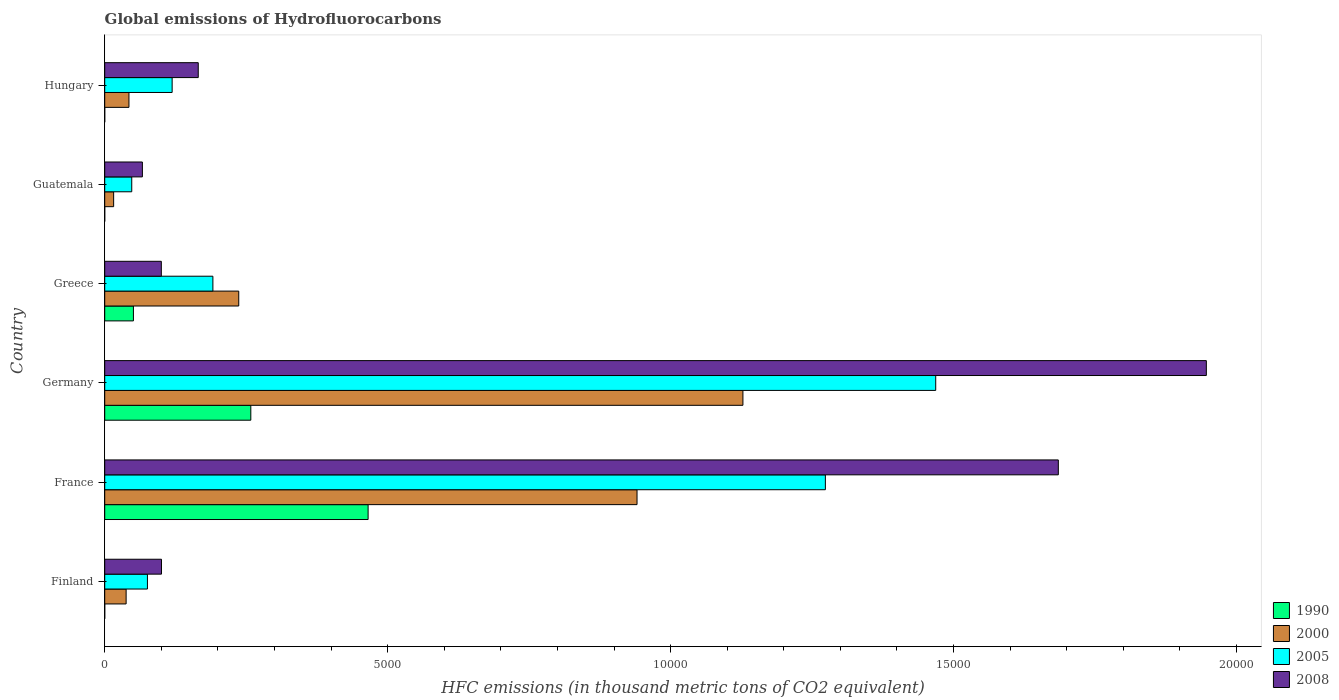How many different coloured bars are there?
Make the answer very short. 4. In how many cases, is the number of bars for a given country not equal to the number of legend labels?
Provide a succinct answer. 0. What is the global emissions of Hydrofluorocarbons in 2000 in Germany?
Your answer should be very brief. 1.13e+04. Across all countries, what is the maximum global emissions of Hydrofluorocarbons in 2000?
Provide a succinct answer. 1.13e+04. Across all countries, what is the minimum global emissions of Hydrofluorocarbons in 2008?
Your answer should be compact. 665.8. In which country was the global emissions of Hydrofluorocarbons in 2008 maximum?
Offer a terse response. Germany. In which country was the global emissions of Hydrofluorocarbons in 2005 minimum?
Keep it short and to the point. Guatemala. What is the total global emissions of Hydrofluorocarbons in 1990 in the graph?
Offer a terse response. 7743.3. What is the difference between the global emissions of Hydrofluorocarbons in 2000 in France and that in Greece?
Your answer should be very brief. 7038. What is the difference between the global emissions of Hydrofluorocarbons in 1990 in Greece and the global emissions of Hydrofluorocarbons in 2000 in Hungary?
Offer a very short reply. 79. What is the average global emissions of Hydrofluorocarbons in 2008 per country?
Your answer should be very brief. 6773.35. What is the difference between the global emissions of Hydrofluorocarbons in 2000 and global emissions of Hydrofluorocarbons in 1990 in Finland?
Keep it short and to the point. 378.1. What is the ratio of the global emissions of Hydrofluorocarbons in 1990 in Finland to that in Guatemala?
Your response must be concise. 1. Is the difference between the global emissions of Hydrofluorocarbons in 2000 in Greece and Hungary greater than the difference between the global emissions of Hydrofluorocarbons in 1990 in Greece and Hungary?
Keep it short and to the point. Yes. What is the difference between the highest and the second highest global emissions of Hydrofluorocarbons in 2005?
Your answer should be compact. 1949.9. What is the difference between the highest and the lowest global emissions of Hydrofluorocarbons in 2005?
Make the answer very short. 1.42e+04. Is it the case that in every country, the sum of the global emissions of Hydrofluorocarbons in 1990 and global emissions of Hydrofluorocarbons in 2005 is greater than the sum of global emissions of Hydrofluorocarbons in 2008 and global emissions of Hydrofluorocarbons in 2000?
Provide a succinct answer. No. Is it the case that in every country, the sum of the global emissions of Hydrofluorocarbons in 2005 and global emissions of Hydrofluorocarbons in 2008 is greater than the global emissions of Hydrofluorocarbons in 1990?
Give a very brief answer. Yes. How many countries are there in the graph?
Ensure brevity in your answer.  6. What is the difference between two consecutive major ticks on the X-axis?
Give a very brief answer. 5000. Does the graph contain any zero values?
Ensure brevity in your answer.  No. How are the legend labels stacked?
Provide a short and direct response. Vertical. What is the title of the graph?
Keep it short and to the point. Global emissions of Hydrofluorocarbons. What is the label or title of the X-axis?
Give a very brief answer. HFC emissions (in thousand metric tons of CO2 equivalent). What is the label or title of the Y-axis?
Your answer should be very brief. Country. What is the HFC emissions (in thousand metric tons of CO2 equivalent) in 1990 in Finland?
Provide a short and direct response. 0.1. What is the HFC emissions (in thousand metric tons of CO2 equivalent) in 2000 in Finland?
Give a very brief answer. 378.2. What is the HFC emissions (in thousand metric tons of CO2 equivalent) of 2005 in Finland?
Keep it short and to the point. 754.9. What is the HFC emissions (in thousand metric tons of CO2 equivalent) in 2008 in Finland?
Ensure brevity in your answer.  1003.2. What is the HFC emissions (in thousand metric tons of CO2 equivalent) of 1990 in France?
Offer a terse response. 4654.3. What is the HFC emissions (in thousand metric tons of CO2 equivalent) of 2000 in France?
Keep it short and to the point. 9406.4. What is the HFC emissions (in thousand metric tons of CO2 equivalent) in 2005 in France?
Provide a short and direct response. 1.27e+04. What is the HFC emissions (in thousand metric tons of CO2 equivalent) in 2008 in France?
Your answer should be very brief. 1.69e+04. What is the HFC emissions (in thousand metric tons of CO2 equivalent) in 1990 in Germany?
Keep it short and to the point. 2581.5. What is the HFC emissions (in thousand metric tons of CO2 equivalent) of 2000 in Germany?
Offer a very short reply. 1.13e+04. What is the HFC emissions (in thousand metric tons of CO2 equivalent) in 2005 in Germany?
Ensure brevity in your answer.  1.47e+04. What is the HFC emissions (in thousand metric tons of CO2 equivalent) of 2008 in Germany?
Ensure brevity in your answer.  1.95e+04. What is the HFC emissions (in thousand metric tons of CO2 equivalent) in 1990 in Greece?
Make the answer very short. 507.2. What is the HFC emissions (in thousand metric tons of CO2 equivalent) in 2000 in Greece?
Keep it short and to the point. 2368.4. What is the HFC emissions (in thousand metric tons of CO2 equivalent) of 2005 in Greece?
Your answer should be very brief. 1911.4. What is the HFC emissions (in thousand metric tons of CO2 equivalent) of 2008 in Greece?
Your answer should be compact. 1000.3. What is the HFC emissions (in thousand metric tons of CO2 equivalent) in 1990 in Guatemala?
Make the answer very short. 0.1. What is the HFC emissions (in thousand metric tons of CO2 equivalent) of 2000 in Guatemala?
Offer a terse response. 157.6. What is the HFC emissions (in thousand metric tons of CO2 equivalent) of 2005 in Guatemala?
Your answer should be compact. 477.8. What is the HFC emissions (in thousand metric tons of CO2 equivalent) in 2008 in Guatemala?
Offer a terse response. 665.8. What is the HFC emissions (in thousand metric tons of CO2 equivalent) of 2000 in Hungary?
Your response must be concise. 428.2. What is the HFC emissions (in thousand metric tons of CO2 equivalent) of 2005 in Hungary?
Make the answer very short. 1191.4. What is the HFC emissions (in thousand metric tons of CO2 equivalent) in 2008 in Hungary?
Your answer should be compact. 1652.9. Across all countries, what is the maximum HFC emissions (in thousand metric tons of CO2 equivalent) of 1990?
Ensure brevity in your answer.  4654.3. Across all countries, what is the maximum HFC emissions (in thousand metric tons of CO2 equivalent) of 2000?
Provide a succinct answer. 1.13e+04. Across all countries, what is the maximum HFC emissions (in thousand metric tons of CO2 equivalent) in 2005?
Offer a terse response. 1.47e+04. Across all countries, what is the maximum HFC emissions (in thousand metric tons of CO2 equivalent) in 2008?
Keep it short and to the point. 1.95e+04. Across all countries, what is the minimum HFC emissions (in thousand metric tons of CO2 equivalent) in 1990?
Provide a succinct answer. 0.1. Across all countries, what is the minimum HFC emissions (in thousand metric tons of CO2 equivalent) in 2000?
Provide a short and direct response. 157.6. Across all countries, what is the minimum HFC emissions (in thousand metric tons of CO2 equivalent) in 2005?
Your answer should be compact. 477.8. Across all countries, what is the minimum HFC emissions (in thousand metric tons of CO2 equivalent) of 2008?
Give a very brief answer. 665.8. What is the total HFC emissions (in thousand metric tons of CO2 equivalent) of 1990 in the graph?
Your response must be concise. 7743.3. What is the total HFC emissions (in thousand metric tons of CO2 equivalent) of 2000 in the graph?
Offer a very short reply. 2.40e+04. What is the total HFC emissions (in thousand metric tons of CO2 equivalent) in 2005 in the graph?
Give a very brief answer. 3.18e+04. What is the total HFC emissions (in thousand metric tons of CO2 equivalent) of 2008 in the graph?
Your response must be concise. 4.06e+04. What is the difference between the HFC emissions (in thousand metric tons of CO2 equivalent) of 1990 in Finland and that in France?
Offer a terse response. -4654.2. What is the difference between the HFC emissions (in thousand metric tons of CO2 equivalent) of 2000 in Finland and that in France?
Your answer should be compact. -9028.2. What is the difference between the HFC emissions (in thousand metric tons of CO2 equivalent) of 2005 in Finland and that in France?
Make the answer very short. -1.20e+04. What is the difference between the HFC emissions (in thousand metric tons of CO2 equivalent) in 2008 in Finland and that in France?
Give a very brief answer. -1.58e+04. What is the difference between the HFC emissions (in thousand metric tons of CO2 equivalent) of 1990 in Finland and that in Germany?
Ensure brevity in your answer.  -2581.4. What is the difference between the HFC emissions (in thousand metric tons of CO2 equivalent) in 2000 in Finland and that in Germany?
Ensure brevity in your answer.  -1.09e+04. What is the difference between the HFC emissions (in thousand metric tons of CO2 equivalent) of 2005 in Finland and that in Germany?
Provide a short and direct response. -1.39e+04. What is the difference between the HFC emissions (in thousand metric tons of CO2 equivalent) in 2008 in Finland and that in Germany?
Offer a terse response. -1.85e+04. What is the difference between the HFC emissions (in thousand metric tons of CO2 equivalent) of 1990 in Finland and that in Greece?
Your response must be concise. -507.1. What is the difference between the HFC emissions (in thousand metric tons of CO2 equivalent) of 2000 in Finland and that in Greece?
Keep it short and to the point. -1990.2. What is the difference between the HFC emissions (in thousand metric tons of CO2 equivalent) in 2005 in Finland and that in Greece?
Your response must be concise. -1156.5. What is the difference between the HFC emissions (in thousand metric tons of CO2 equivalent) in 2008 in Finland and that in Greece?
Provide a succinct answer. 2.9. What is the difference between the HFC emissions (in thousand metric tons of CO2 equivalent) in 1990 in Finland and that in Guatemala?
Your answer should be compact. 0. What is the difference between the HFC emissions (in thousand metric tons of CO2 equivalent) of 2000 in Finland and that in Guatemala?
Offer a very short reply. 220.6. What is the difference between the HFC emissions (in thousand metric tons of CO2 equivalent) in 2005 in Finland and that in Guatemala?
Offer a very short reply. 277.1. What is the difference between the HFC emissions (in thousand metric tons of CO2 equivalent) of 2008 in Finland and that in Guatemala?
Provide a short and direct response. 337.4. What is the difference between the HFC emissions (in thousand metric tons of CO2 equivalent) in 1990 in Finland and that in Hungary?
Offer a terse response. 0. What is the difference between the HFC emissions (in thousand metric tons of CO2 equivalent) in 2000 in Finland and that in Hungary?
Your response must be concise. -50. What is the difference between the HFC emissions (in thousand metric tons of CO2 equivalent) of 2005 in Finland and that in Hungary?
Ensure brevity in your answer.  -436.5. What is the difference between the HFC emissions (in thousand metric tons of CO2 equivalent) in 2008 in Finland and that in Hungary?
Your response must be concise. -649.7. What is the difference between the HFC emissions (in thousand metric tons of CO2 equivalent) of 1990 in France and that in Germany?
Your response must be concise. 2072.8. What is the difference between the HFC emissions (in thousand metric tons of CO2 equivalent) in 2000 in France and that in Germany?
Your answer should be very brief. -1871.2. What is the difference between the HFC emissions (in thousand metric tons of CO2 equivalent) of 2005 in France and that in Germany?
Provide a short and direct response. -1949.9. What is the difference between the HFC emissions (in thousand metric tons of CO2 equivalent) of 2008 in France and that in Germany?
Your answer should be compact. -2615.7. What is the difference between the HFC emissions (in thousand metric tons of CO2 equivalent) in 1990 in France and that in Greece?
Provide a succinct answer. 4147.1. What is the difference between the HFC emissions (in thousand metric tons of CO2 equivalent) of 2000 in France and that in Greece?
Your response must be concise. 7038. What is the difference between the HFC emissions (in thousand metric tons of CO2 equivalent) in 2005 in France and that in Greece?
Your answer should be compact. 1.08e+04. What is the difference between the HFC emissions (in thousand metric tons of CO2 equivalent) of 2008 in France and that in Greece?
Offer a very short reply. 1.59e+04. What is the difference between the HFC emissions (in thousand metric tons of CO2 equivalent) in 1990 in France and that in Guatemala?
Provide a succinct answer. 4654.2. What is the difference between the HFC emissions (in thousand metric tons of CO2 equivalent) in 2000 in France and that in Guatemala?
Give a very brief answer. 9248.8. What is the difference between the HFC emissions (in thousand metric tons of CO2 equivalent) of 2005 in France and that in Guatemala?
Ensure brevity in your answer.  1.23e+04. What is the difference between the HFC emissions (in thousand metric tons of CO2 equivalent) of 2008 in France and that in Guatemala?
Offer a very short reply. 1.62e+04. What is the difference between the HFC emissions (in thousand metric tons of CO2 equivalent) in 1990 in France and that in Hungary?
Your answer should be compact. 4654.2. What is the difference between the HFC emissions (in thousand metric tons of CO2 equivalent) in 2000 in France and that in Hungary?
Offer a very short reply. 8978.2. What is the difference between the HFC emissions (in thousand metric tons of CO2 equivalent) of 2005 in France and that in Hungary?
Provide a short and direct response. 1.15e+04. What is the difference between the HFC emissions (in thousand metric tons of CO2 equivalent) of 2008 in France and that in Hungary?
Keep it short and to the point. 1.52e+04. What is the difference between the HFC emissions (in thousand metric tons of CO2 equivalent) in 1990 in Germany and that in Greece?
Your answer should be compact. 2074.3. What is the difference between the HFC emissions (in thousand metric tons of CO2 equivalent) in 2000 in Germany and that in Greece?
Provide a succinct answer. 8909.2. What is the difference between the HFC emissions (in thousand metric tons of CO2 equivalent) of 2005 in Germany and that in Greece?
Offer a very short reply. 1.28e+04. What is the difference between the HFC emissions (in thousand metric tons of CO2 equivalent) in 2008 in Germany and that in Greece?
Provide a succinct answer. 1.85e+04. What is the difference between the HFC emissions (in thousand metric tons of CO2 equivalent) in 1990 in Germany and that in Guatemala?
Make the answer very short. 2581.4. What is the difference between the HFC emissions (in thousand metric tons of CO2 equivalent) in 2000 in Germany and that in Guatemala?
Your answer should be very brief. 1.11e+04. What is the difference between the HFC emissions (in thousand metric tons of CO2 equivalent) of 2005 in Germany and that in Guatemala?
Provide a short and direct response. 1.42e+04. What is the difference between the HFC emissions (in thousand metric tons of CO2 equivalent) in 2008 in Germany and that in Guatemala?
Make the answer very short. 1.88e+04. What is the difference between the HFC emissions (in thousand metric tons of CO2 equivalent) in 1990 in Germany and that in Hungary?
Provide a short and direct response. 2581.4. What is the difference between the HFC emissions (in thousand metric tons of CO2 equivalent) in 2000 in Germany and that in Hungary?
Your answer should be compact. 1.08e+04. What is the difference between the HFC emissions (in thousand metric tons of CO2 equivalent) of 2005 in Germany and that in Hungary?
Your answer should be very brief. 1.35e+04. What is the difference between the HFC emissions (in thousand metric tons of CO2 equivalent) of 2008 in Germany and that in Hungary?
Offer a very short reply. 1.78e+04. What is the difference between the HFC emissions (in thousand metric tons of CO2 equivalent) in 1990 in Greece and that in Guatemala?
Offer a terse response. 507.1. What is the difference between the HFC emissions (in thousand metric tons of CO2 equivalent) in 2000 in Greece and that in Guatemala?
Offer a very short reply. 2210.8. What is the difference between the HFC emissions (in thousand metric tons of CO2 equivalent) in 2005 in Greece and that in Guatemala?
Give a very brief answer. 1433.6. What is the difference between the HFC emissions (in thousand metric tons of CO2 equivalent) of 2008 in Greece and that in Guatemala?
Provide a short and direct response. 334.5. What is the difference between the HFC emissions (in thousand metric tons of CO2 equivalent) in 1990 in Greece and that in Hungary?
Provide a short and direct response. 507.1. What is the difference between the HFC emissions (in thousand metric tons of CO2 equivalent) of 2000 in Greece and that in Hungary?
Offer a terse response. 1940.2. What is the difference between the HFC emissions (in thousand metric tons of CO2 equivalent) of 2005 in Greece and that in Hungary?
Give a very brief answer. 720. What is the difference between the HFC emissions (in thousand metric tons of CO2 equivalent) of 2008 in Greece and that in Hungary?
Offer a very short reply. -652.6. What is the difference between the HFC emissions (in thousand metric tons of CO2 equivalent) of 2000 in Guatemala and that in Hungary?
Give a very brief answer. -270.6. What is the difference between the HFC emissions (in thousand metric tons of CO2 equivalent) of 2005 in Guatemala and that in Hungary?
Your response must be concise. -713.6. What is the difference between the HFC emissions (in thousand metric tons of CO2 equivalent) of 2008 in Guatemala and that in Hungary?
Make the answer very short. -987.1. What is the difference between the HFC emissions (in thousand metric tons of CO2 equivalent) of 1990 in Finland and the HFC emissions (in thousand metric tons of CO2 equivalent) of 2000 in France?
Ensure brevity in your answer.  -9406.3. What is the difference between the HFC emissions (in thousand metric tons of CO2 equivalent) in 1990 in Finland and the HFC emissions (in thousand metric tons of CO2 equivalent) in 2005 in France?
Make the answer very short. -1.27e+04. What is the difference between the HFC emissions (in thousand metric tons of CO2 equivalent) in 1990 in Finland and the HFC emissions (in thousand metric tons of CO2 equivalent) in 2008 in France?
Your answer should be very brief. -1.69e+04. What is the difference between the HFC emissions (in thousand metric tons of CO2 equivalent) in 2000 in Finland and the HFC emissions (in thousand metric tons of CO2 equivalent) in 2005 in France?
Offer a very short reply. -1.24e+04. What is the difference between the HFC emissions (in thousand metric tons of CO2 equivalent) of 2000 in Finland and the HFC emissions (in thousand metric tons of CO2 equivalent) of 2008 in France?
Your response must be concise. -1.65e+04. What is the difference between the HFC emissions (in thousand metric tons of CO2 equivalent) of 2005 in Finland and the HFC emissions (in thousand metric tons of CO2 equivalent) of 2008 in France?
Your answer should be very brief. -1.61e+04. What is the difference between the HFC emissions (in thousand metric tons of CO2 equivalent) of 1990 in Finland and the HFC emissions (in thousand metric tons of CO2 equivalent) of 2000 in Germany?
Provide a short and direct response. -1.13e+04. What is the difference between the HFC emissions (in thousand metric tons of CO2 equivalent) of 1990 in Finland and the HFC emissions (in thousand metric tons of CO2 equivalent) of 2005 in Germany?
Provide a succinct answer. -1.47e+04. What is the difference between the HFC emissions (in thousand metric tons of CO2 equivalent) in 1990 in Finland and the HFC emissions (in thousand metric tons of CO2 equivalent) in 2008 in Germany?
Keep it short and to the point. -1.95e+04. What is the difference between the HFC emissions (in thousand metric tons of CO2 equivalent) in 2000 in Finland and the HFC emissions (in thousand metric tons of CO2 equivalent) in 2005 in Germany?
Provide a succinct answer. -1.43e+04. What is the difference between the HFC emissions (in thousand metric tons of CO2 equivalent) of 2000 in Finland and the HFC emissions (in thousand metric tons of CO2 equivalent) of 2008 in Germany?
Keep it short and to the point. -1.91e+04. What is the difference between the HFC emissions (in thousand metric tons of CO2 equivalent) in 2005 in Finland and the HFC emissions (in thousand metric tons of CO2 equivalent) in 2008 in Germany?
Your response must be concise. -1.87e+04. What is the difference between the HFC emissions (in thousand metric tons of CO2 equivalent) in 1990 in Finland and the HFC emissions (in thousand metric tons of CO2 equivalent) in 2000 in Greece?
Your answer should be compact. -2368.3. What is the difference between the HFC emissions (in thousand metric tons of CO2 equivalent) of 1990 in Finland and the HFC emissions (in thousand metric tons of CO2 equivalent) of 2005 in Greece?
Ensure brevity in your answer.  -1911.3. What is the difference between the HFC emissions (in thousand metric tons of CO2 equivalent) of 1990 in Finland and the HFC emissions (in thousand metric tons of CO2 equivalent) of 2008 in Greece?
Offer a very short reply. -1000.2. What is the difference between the HFC emissions (in thousand metric tons of CO2 equivalent) of 2000 in Finland and the HFC emissions (in thousand metric tons of CO2 equivalent) of 2005 in Greece?
Your response must be concise. -1533.2. What is the difference between the HFC emissions (in thousand metric tons of CO2 equivalent) in 2000 in Finland and the HFC emissions (in thousand metric tons of CO2 equivalent) in 2008 in Greece?
Provide a short and direct response. -622.1. What is the difference between the HFC emissions (in thousand metric tons of CO2 equivalent) of 2005 in Finland and the HFC emissions (in thousand metric tons of CO2 equivalent) of 2008 in Greece?
Provide a short and direct response. -245.4. What is the difference between the HFC emissions (in thousand metric tons of CO2 equivalent) in 1990 in Finland and the HFC emissions (in thousand metric tons of CO2 equivalent) in 2000 in Guatemala?
Your answer should be very brief. -157.5. What is the difference between the HFC emissions (in thousand metric tons of CO2 equivalent) of 1990 in Finland and the HFC emissions (in thousand metric tons of CO2 equivalent) of 2005 in Guatemala?
Offer a very short reply. -477.7. What is the difference between the HFC emissions (in thousand metric tons of CO2 equivalent) of 1990 in Finland and the HFC emissions (in thousand metric tons of CO2 equivalent) of 2008 in Guatemala?
Your response must be concise. -665.7. What is the difference between the HFC emissions (in thousand metric tons of CO2 equivalent) of 2000 in Finland and the HFC emissions (in thousand metric tons of CO2 equivalent) of 2005 in Guatemala?
Your response must be concise. -99.6. What is the difference between the HFC emissions (in thousand metric tons of CO2 equivalent) in 2000 in Finland and the HFC emissions (in thousand metric tons of CO2 equivalent) in 2008 in Guatemala?
Offer a terse response. -287.6. What is the difference between the HFC emissions (in thousand metric tons of CO2 equivalent) in 2005 in Finland and the HFC emissions (in thousand metric tons of CO2 equivalent) in 2008 in Guatemala?
Ensure brevity in your answer.  89.1. What is the difference between the HFC emissions (in thousand metric tons of CO2 equivalent) of 1990 in Finland and the HFC emissions (in thousand metric tons of CO2 equivalent) of 2000 in Hungary?
Give a very brief answer. -428.1. What is the difference between the HFC emissions (in thousand metric tons of CO2 equivalent) of 1990 in Finland and the HFC emissions (in thousand metric tons of CO2 equivalent) of 2005 in Hungary?
Keep it short and to the point. -1191.3. What is the difference between the HFC emissions (in thousand metric tons of CO2 equivalent) in 1990 in Finland and the HFC emissions (in thousand metric tons of CO2 equivalent) in 2008 in Hungary?
Give a very brief answer. -1652.8. What is the difference between the HFC emissions (in thousand metric tons of CO2 equivalent) in 2000 in Finland and the HFC emissions (in thousand metric tons of CO2 equivalent) in 2005 in Hungary?
Your response must be concise. -813.2. What is the difference between the HFC emissions (in thousand metric tons of CO2 equivalent) in 2000 in Finland and the HFC emissions (in thousand metric tons of CO2 equivalent) in 2008 in Hungary?
Ensure brevity in your answer.  -1274.7. What is the difference between the HFC emissions (in thousand metric tons of CO2 equivalent) in 2005 in Finland and the HFC emissions (in thousand metric tons of CO2 equivalent) in 2008 in Hungary?
Offer a terse response. -898. What is the difference between the HFC emissions (in thousand metric tons of CO2 equivalent) of 1990 in France and the HFC emissions (in thousand metric tons of CO2 equivalent) of 2000 in Germany?
Make the answer very short. -6623.3. What is the difference between the HFC emissions (in thousand metric tons of CO2 equivalent) in 1990 in France and the HFC emissions (in thousand metric tons of CO2 equivalent) in 2005 in Germany?
Your answer should be compact. -1.00e+04. What is the difference between the HFC emissions (in thousand metric tons of CO2 equivalent) in 1990 in France and the HFC emissions (in thousand metric tons of CO2 equivalent) in 2008 in Germany?
Ensure brevity in your answer.  -1.48e+04. What is the difference between the HFC emissions (in thousand metric tons of CO2 equivalent) in 2000 in France and the HFC emissions (in thousand metric tons of CO2 equivalent) in 2005 in Germany?
Keep it short and to the point. -5278.2. What is the difference between the HFC emissions (in thousand metric tons of CO2 equivalent) in 2000 in France and the HFC emissions (in thousand metric tons of CO2 equivalent) in 2008 in Germany?
Provide a short and direct response. -1.01e+04. What is the difference between the HFC emissions (in thousand metric tons of CO2 equivalent) in 2005 in France and the HFC emissions (in thousand metric tons of CO2 equivalent) in 2008 in Germany?
Provide a succinct answer. -6732.1. What is the difference between the HFC emissions (in thousand metric tons of CO2 equivalent) in 1990 in France and the HFC emissions (in thousand metric tons of CO2 equivalent) in 2000 in Greece?
Your response must be concise. 2285.9. What is the difference between the HFC emissions (in thousand metric tons of CO2 equivalent) of 1990 in France and the HFC emissions (in thousand metric tons of CO2 equivalent) of 2005 in Greece?
Offer a very short reply. 2742.9. What is the difference between the HFC emissions (in thousand metric tons of CO2 equivalent) in 1990 in France and the HFC emissions (in thousand metric tons of CO2 equivalent) in 2008 in Greece?
Make the answer very short. 3654. What is the difference between the HFC emissions (in thousand metric tons of CO2 equivalent) of 2000 in France and the HFC emissions (in thousand metric tons of CO2 equivalent) of 2005 in Greece?
Your response must be concise. 7495. What is the difference between the HFC emissions (in thousand metric tons of CO2 equivalent) of 2000 in France and the HFC emissions (in thousand metric tons of CO2 equivalent) of 2008 in Greece?
Provide a short and direct response. 8406.1. What is the difference between the HFC emissions (in thousand metric tons of CO2 equivalent) of 2005 in France and the HFC emissions (in thousand metric tons of CO2 equivalent) of 2008 in Greece?
Keep it short and to the point. 1.17e+04. What is the difference between the HFC emissions (in thousand metric tons of CO2 equivalent) of 1990 in France and the HFC emissions (in thousand metric tons of CO2 equivalent) of 2000 in Guatemala?
Your response must be concise. 4496.7. What is the difference between the HFC emissions (in thousand metric tons of CO2 equivalent) of 1990 in France and the HFC emissions (in thousand metric tons of CO2 equivalent) of 2005 in Guatemala?
Offer a very short reply. 4176.5. What is the difference between the HFC emissions (in thousand metric tons of CO2 equivalent) in 1990 in France and the HFC emissions (in thousand metric tons of CO2 equivalent) in 2008 in Guatemala?
Your answer should be very brief. 3988.5. What is the difference between the HFC emissions (in thousand metric tons of CO2 equivalent) in 2000 in France and the HFC emissions (in thousand metric tons of CO2 equivalent) in 2005 in Guatemala?
Offer a terse response. 8928.6. What is the difference between the HFC emissions (in thousand metric tons of CO2 equivalent) of 2000 in France and the HFC emissions (in thousand metric tons of CO2 equivalent) of 2008 in Guatemala?
Give a very brief answer. 8740.6. What is the difference between the HFC emissions (in thousand metric tons of CO2 equivalent) of 2005 in France and the HFC emissions (in thousand metric tons of CO2 equivalent) of 2008 in Guatemala?
Your answer should be compact. 1.21e+04. What is the difference between the HFC emissions (in thousand metric tons of CO2 equivalent) of 1990 in France and the HFC emissions (in thousand metric tons of CO2 equivalent) of 2000 in Hungary?
Offer a terse response. 4226.1. What is the difference between the HFC emissions (in thousand metric tons of CO2 equivalent) of 1990 in France and the HFC emissions (in thousand metric tons of CO2 equivalent) of 2005 in Hungary?
Provide a short and direct response. 3462.9. What is the difference between the HFC emissions (in thousand metric tons of CO2 equivalent) of 1990 in France and the HFC emissions (in thousand metric tons of CO2 equivalent) of 2008 in Hungary?
Offer a very short reply. 3001.4. What is the difference between the HFC emissions (in thousand metric tons of CO2 equivalent) of 2000 in France and the HFC emissions (in thousand metric tons of CO2 equivalent) of 2005 in Hungary?
Offer a terse response. 8215. What is the difference between the HFC emissions (in thousand metric tons of CO2 equivalent) of 2000 in France and the HFC emissions (in thousand metric tons of CO2 equivalent) of 2008 in Hungary?
Your response must be concise. 7753.5. What is the difference between the HFC emissions (in thousand metric tons of CO2 equivalent) in 2005 in France and the HFC emissions (in thousand metric tons of CO2 equivalent) in 2008 in Hungary?
Your answer should be very brief. 1.11e+04. What is the difference between the HFC emissions (in thousand metric tons of CO2 equivalent) of 1990 in Germany and the HFC emissions (in thousand metric tons of CO2 equivalent) of 2000 in Greece?
Your answer should be compact. 213.1. What is the difference between the HFC emissions (in thousand metric tons of CO2 equivalent) of 1990 in Germany and the HFC emissions (in thousand metric tons of CO2 equivalent) of 2005 in Greece?
Offer a terse response. 670.1. What is the difference between the HFC emissions (in thousand metric tons of CO2 equivalent) in 1990 in Germany and the HFC emissions (in thousand metric tons of CO2 equivalent) in 2008 in Greece?
Your response must be concise. 1581.2. What is the difference between the HFC emissions (in thousand metric tons of CO2 equivalent) in 2000 in Germany and the HFC emissions (in thousand metric tons of CO2 equivalent) in 2005 in Greece?
Make the answer very short. 9366.2. What is the difference between the HFC emissions (in thousand metric tons of CO2 equivalent) of 2000 in Germany and the HFC emissions (in thousand metric tons of CO2 equivalent) of 2008 in Greece?
Keep it short and to the point. 1.03e+04. What is the difference between the HFC emissions (in thousand metric tons of CO2 equivalent) of 2005 in Germany and the HFC emissions (in thousand metric tons of CO2 equivalent) of 2008 in Greece?
Your answer should be very brief. 1.37e+04. What is the difference between the HFC emissions (in thousand metric tons of CO2 equivalent) of 1990 in Germany and the HFC emissions (in thousand metric tons of CO2 equivalent) of 2000 in Guatemala?
Your answer should be compact. 2423.9. What is the difference between the HFC emissions (in thousand metric tons of CO2 equivalent) of 1990 in Germany and the HFC emissions (in thousand metric tons of CO2 equivalent) of 2005 in Guatemala?
Your answer should be compact. 2103.7. What is the difference between the HFC emissions (in thousand metric tons of CO2 equivalent) in 1990 in Germany and the HFC emissions (in thousand metric tons of CO2 equivalent) in 2008 in Guatemala?
Ensure brevity in your answer.  1915.7. What is the difference between the HFC emissions (in thousand metric tons of CO2 equivalent) of 2000 in Germany and the HFC emissions (in thousand metric tons of CO2 equivalent) of 2005 in Guatemala?
Provide a succinct answer. 1.08e+04. What is the difference between the HFC emissions (in thousand metric tons of CO2 equivalent) in 2000 in Germany and the HFC emissions (in thousand metric tons of CO2 equivalent) in 2008 in Guatemala?
Make the answer very short. 1.06e+04. What is the difference between the HFC emissions (in thousand metric tons of CO2 equivalent) of 2005 in Germany and the HFC emissions (in thousand metric tons of CO2 equivalent) of 2008 in Guatemala?
Your answer should be very brief. 1.40e+04. What is the difference between the HFC emissions (in thousand metric tons of CO2 equivalent) of 1990 in Germany and the HFC emissions (in thousand metric tons of CO2 equivalent) of 2000 in Hungary?
Offer a terse response. 2153.3. What is the difference between the HFC emissions (in thousand metric tons of CO2 equivalent) of 1990 in Germany and the HFC emissions (in thousand metric tons of CO2 equivalent) of 2005 in Hungary?
Your answer should be compact. 1390.1. What is the difference between the HFC emissions (in thousand metric tons of CO2 equivalent) of 1990 in Germany and the HFC emissions (in thousand metric tons of CO2 equivalent) of 2008 in Hungary?
Provide a succinct answer. 928.6. What is the difference between the HFC emissions (in thousand metric tons of CO2 equivalent) of 2000 in Germany and the HFC emissions (in thousand metric tons of CO2 equivalent) of 2005 in Hungary?
Your response must be concise. 1.01e+04. What is the difference between the HFC emissions (in thousand metric tons of CO2 equivalent) of 2000 in Germany and the HFC emissions (in thousand metric tons of CO2 equivalent) of 2008 in Hungary?
Provide a succinct answer. 9624.7. What is the difference between the HFC emissions (in thousand metric tons of CO2 equivalent) of 2005 in Germany and the HFC emissions (in thousand metric tons of CO2 equivalent) of 2008 in Hungary?
Your response must be concise. 1.30e+04. What is the difference between the HFC emissions (in thousand metric tons of CO2 equivalent) in 1990 in Greece and the HFC emissions (in thousand metric tons of CO2 equivalent) in 2000 in Guatemala?
Keep it short and to the point. 349.6. What is the difference between the HFC emissions (in thousand metric tons of CO2 equivalent) of 1990 in Greece and the HFC emissions (in thousand metric tons of CO2 equivalent) of 2005 in Guatemala?
Offer a very short reply. 29.4. What is the difference between the HFC emissions (in thousand metric tons of CO2 equivalent) of 1990 in Greece and the HFC emissions (in thousand metric tons of CO2 equivalent) of 2008 in Guatemala?
Your answer should be compact. -158.6. What is the difference between the HFC emissions (in thousand metric tons of CO2 equivalent) in 2000 in Greece and the HFC emissions (in thousand metric tons of CO2 equivalent) in 2005 in Guatemala?
Make the answer very short. 1890.6. What is the difference between the HFC emissions (in thousand metric tons of CO2 equivalent) in 2000 in Greece and the HFC emissions (in thousand metric tons of CO2 equivalent) in 2008 in Guatemala?
Keep it short and to the point. 1702.6. What is the difference between the HFC emissions (in thousand metric tons of CO2 equivalent) in 2005 in Greece and the HFC emissions (in thousand metric tons of CO2 equivalent) in 2008 in Guatemala?
Offer a very short reply. 1245.6. What is the difference between the HFC emissions (in thousand metric tons of CO2 equivalent) of 1990 in Greece and the HFC emissions (in thousand metric tons of CO2 equivalent) of 2000 in Hungary?
Offer a terse response. 79. What is the difference between the HFC emissions (in thousand metric tons of CO2 equivalent) of 1990 in Greece and the HFC emissions (in thousand metric tons of CO2 equivalent) of 2005 in Hungary?
Your answer should be compact. -684.2. What is the difference between the HFC emissions (in thousand metric tons of CO2 equivalent) of 1990 in Greece and the HFC emissions (in thousand metric tons of CO2 equivalent) of 2008 in Hungary?
Keep it short and to the point. -1145.7. What is the difference between the HFC emissions (in thousand metric tons of CO2 equivalent) in 2000 in Greece and the HFC emissions (in thousand metric tons of CO2 equivalent) in 2005 in Hungary?
Ensure brevity in your answer.  1177. What is the difference between the HFC emissions (in thousand metric tons of CO2 equivalent) of 2000 in Greece and the HFC emissions (in thousand metric tons of CO2 equivalent) of 2008 in Hungary?
Your response must be concise. 715.5. What is the difference between the HFC emissions (in thousand metric tons of CO2 equivalent) of 2005 in Greece and the HFC emissions (in thousand metric tons of CO2 equivalent) of 2008 in Hungary?
Offer a very short reply. 258.5. What is the difference between the HFC emissions (in thousand metric tons of CO2 equivalent) of 1990 in Guatemala and the HFC emissions (in thousand metric tons of CO2 equivalent) of 2000 in Hungary?
Provide a short and direct response. -428.1. What is the difference between the HFC emissions (in thousand metric tons of CO2 equivalent) of 1990 in Guatemala and the HFC emissions (in thousand metric tons of CO2 equivalent) of 2005 in Hungary?
Keep it short and to the point. -1191.3. What is the difference between the HFC emissions (in thousand metric tons of CO2 equivalent) of 1990 in Guatemala and the HFC emissions (in thousand metric tons of CO2 equivalent) of 2008 in Hungary?
Offer a terse response. -1652.8. What is the difference between the HFC emissions (in thousand metric tons of CO2 equivalent) in 2000 in Guatemala and the HFC emissions (in thousand metric tons of CO2 equivalent) in 2005 in Hungary?
Provide a short and direct response. -1033.8. What is the difference between the HFC emissions (in thousand metric tons of CO2 equivalent) of 2000 in Guatemala and the HFC emissions (in thousand metric tons of CO2 equivalent) of 2008 in Hungary?
Provide a succinct answer. -1495.3. What is the difference between the HFC emissions (in thousand metric tons of CO2 equivalent) of 2005 in Guatemala and the HFC emissions (in thousand metric tons of CO2 equivalent) of 2008 in Hungary?
Provide a succinct answer. -1175.1. What is the average HFC emissions (in thousand metric tons of CO2 equivalent) in 1990 per country?
Offer a very short reply. 1290.55. What is the average HFC emissions (in thousand metric tons of CO2 equivalent) of 2000 per country?
Offer a terse response. 4002.73. What is the average HFC emissions (in thousand metric tons of CO2 equivalent) of 2005 per country?
Offer a very short reply. 5292.47. What is the average HFC emissions (in thousand metric tons of CO2 equivalent) in 2008 per country?
Your answer should be very brief. 6773.35. What is the difference between the HFC emissions (in thousand metric tons of CO2 equivalent) in 1990 and HFC emissions (in thousand metric tons of CO2 equivalent) in 2000 in Finland?
Provide a succinct answer. -378.1. What is the difference between the HFC emissions (in thousand metric tons of CO2 equivalent) of 1990 and HFC emissions (in thousand metric tons of CO2 equivalent) of 2005 in Finland?
Ensure brevity in your answer.  -754.8. What is the difference between the HFC emissions (in thousand metric tons of CO2 equivalent) in 1990 and HFC emissions (in thousand metric tons of CO2 equivalent) in 2008 in Finland?
Provide a succinct answer. -1003.1. What is the difference between the HFC emissions (in thousand metric tons of CO2 equivalent) of 2000 and HFC emissions (in thousand metric tons of CO2 equivalent) of 2005 in Finland?
Your answer should be compact. -376.7. What is the difference between the HFC emissions (in thousand metric tons of CO2 equivalent) in 2000 and HFC emissions (in thousand metric tons of CO2 equivalent) in 2008 in Finland?
Your answer should be very brief. -625. What is the difference between the HFC emissions (in thousand metric tons of CO2 equivalent) in 2005 and HFC emissions (in thousand metric tons of CO2 equivalent) in 2008 in Finland?
Make the answer very short. -248.3. What is the difference between the HFC emissions (in thousand metric tons of CO2 equivalent) in 1990 and HFC emissions (in thousand metric tons of CO2 equivalent) in 2000 in France?
Provide a short and direct response. -4752.1. What is the difference between the HFC emissions (in thousand metric tons of CO2 equivalent) of 1990 and HFC emissions (in thousand metric tons of CO2 equivalent) of 2005 in France?
Your response must be concise. -8080.4. What is the difference between the HFC emissions (in thousand metric tons of CO2 equivalent) of 1990 and HFC emissions (in thousand metric tons of CO2 equivalent) of 2008 in France?
Keep it short and to the point. -1.22e+04. What is the difference between the HFC emissions (in thousand metric tons of CO2 equivalent) of 2000 and HFC emissions (in thousand metric tons of CO2 equivalent) of 2005 in France?
Offer a very short reply. -3328.3. What is the difference between the HFC emissions (in thousand metric tons of CO2 equivalent) of 2000 and HFC emissions (in thousand metric tons of CO2 equivalent) of 2008 in France?
Make the answer very short. -7444.7. What is the difference between the HFC emissions (in thousand metric tons of CO2 equivalent) in 2005 and HFC emissions (in thousand metric tons of CO2 equivalent) in 2008 in France?
Ensure brevity in your answer.  -4116.4. What is the difference between the HFC emissions (in thousand metric tons of CO2 equivalent) in 1990 and HFC emissions (in thousand metric tons of CO2 equivalent) in 2000 in Germany?
Make the answer very short. -8696.1. What is the difference between the HFC emissions (in thousand metric tons of CO2 equivalent) of 1990 and HFC emissions (in thousand metric tons of CO2 equivalent) of 2005 in Germany?
Offer a terse response. -1.21e+04. What is the difference between the HFC emissions (in thousand metric tons of CO2 equivalent) of 1990 and HFC emissions (in thousand metric tons of CO2 equivalent) of 2008 in Germany?
Provide a short and direct response. -1.69e+04. What is the difference between the HFC emissions (in thousand metric tons of CO2 equivalent) of 2000 and HFC emissions (in thousand metric tons of CO2 equivalent) of 2005 in Germany?
Keep it short and to the point. -3407. What is the difference between the HFC emissions (in thousand metric tons of CO2 equivalent) of 2000 and HFC emissions (in thousand metric tons of CO2 equivalent) of 2008 in Germany?
Offer a terse response. -8189.2. What is the difference between the HFC emissions (in thousand metric tons of CO2 equivalent) of 2005 and HFC emissions (in thousand metric tons of CO2 equivalent) of 2008 in Germany?
Offer a very short reply. -4782.2. What is the difference between the HFC emissions (in thousand metric tons of CO2 equivalent) of 1990 and HFC emissions (in thousand metric tons of CO2 equivalent) of 2000 in Greece?
Offer a very short reply. -1861.2. What is the difference between the HFC emissions (in thousand metric tons of CO2 equivalent) in 1990 and HFC emissions (in thousand metric tons of CO2 equivalent) in 2005 in Greece?
Your answer should be compact. -1404.2. What is the difference between the HFC emissions (in thousand metric tons of CO2 equivalent) of 1990 and HFC emissions (in thousand metric tons of CO2 equivalent) of 2008 in Greece?
Offer a very short reply. -493.1. What is the difference between the HFC emissions (in thousand metric tons of CO2 equivalent) of 2000 and HFC emissions (in thousand metric tons of CO2 equivalent) of 2005 in Greece?
Make the answer very short. 457. What is the difference between the HFC emissions (in thousand metric tons of CO2 equivalent) in 2000 and HFC emissions (in thousand metric tons of CO2 equivalent) in 2008 in Greece?
Give a very brief answer. 1368.1. What is the difference between the HFC emissions (in thousand metric tons of CO2 equivalent) in 2005 and HFC emissions (in thousand metric tons of CO2 equivalent) in 2008 in Greece?
Your response must be concise. 911.1. What is the difference between the HFC emissions (in thousand metric tons of CO2 equivalent) in 1990 and HFC emissions (in thousand metric tons of CO2 equivalent) in 2000 in Guatemala?
Make the answer very short. -157.5. What is the difference between the HFC emissions (in thousand metric tons of CO2 equivalent) of 1990 and HFC emissions (in thousand metric tons of CO2 equivalent) of 2005 in Guatemala?
Give a very brief answer. -477.7. What is the difference between the HFC emissions (in thousand metric tons of CO2 equivalent) of 1990 and HFC emissions (in thousand metric tons of CO2 equivalent) of 2008 in Guatemala?
Make the answer very short. -665.7. What is the difference between the HFC emissions (in thousand metric tons of CO2 equivalent) of 2000 and HFC emissions (in thousand metric tons of CO2 equivalent) of 2005 in Guatemala?
Ensure brevity in your answer.  -320.2. What is the difference between the HFC emissions (in thousand metric tons of CO2 equivalent) of 2000 and HFC emissions (in thousand metric tons of CO2 equivalent) of 2008 in Guatemala?
Your answer should be very brief. -508.2. What is the difference between the HFC emissions (in thousand metric tons of CO2 equivalent) of 2005 and HFC emissions (in thousand metric tons of CO2 equivalent) of 2008 in Guatemala?
Your answer should be very brief. -188. What is the difference between the HFC emissions (in thousand metric tons of CO2 equivalent) in 1990 and HFC emissions (in thousand metric tons of CO2 equivalent) in 2000 in Hungary?
Offer a very short reply. -428.1. What is the difference between the HFC emissions (in thousand metric tons of CO2 equivalent) in 1990 and HFC emissions (in thousand metric tons of CO2 equivalent) in 2005 in Hungary?
Offer a very short reply. -1191.3. What is the difference between the HFC emissions (in thousand metric tons of CO2 equivalent) in 1990 and HFC emissions (in thousand metric tons of CO2 equivalent) in 2008 in Hungary?
Give a very brief answer. -1652.8. What is the difference between the HFC emissions (in thousand metric tons of CO2 equivalent) in 2000 and HFC emissions (in thousand metric tons of CO2 equivalent) in 2005 in Hungary?
Keep it short and to the point. -763.2. What is the difference between the HFC emissions (in thousand metric tons of CO2 equivalent) in 2000 and HFC emissions (in thousand metric tons of CO2 equivalent) in 2008 in Hungary?
Make the answer very short. -1224.7. What is the difference between the HFC emissions (in thousand metric tons of CO2 equivalent) in 2005 and HFC emissions (in thousand metric tons of CO2 equivalent) in 2008 in Hungary?
Your response must be concise. -461.5. What is the ratio of the HFC emissions (in thousand metric tons of CO2 equivalent) of 1990 in Finland to that in France?
Provide a short and direct response. 0. What is the ratio of the HFC emissions (in thousand metric tons of CO2 equivalent) in 2000 in Finland to that in France?
Your response must be concise. 0.04. What is the ratio of the HFC emissions (in thousand metric tons of CO2 equivalent) in 2005 in Finland to that in France?
Give a very brief answer. 0.06. What is the ratio of the HFC emissions (in thousand metric tons of CO2 equivalent) of 2008 in Finland to that in France?
Provide a succinct answer. 0.06. What is the ratio of the HFC emissions (in thousand metric tons of CO2 equivalent) of 1990 in Finland to that in Germany?
Your answer should be very brief. 0. What is the ratio of the HFC emissions (in thousand metric tons of CO2 equivalent) in 2000 in Finland to that in Germany?
Provide a short and direct response. 0.03. What is the ratio of the HFC emissions (in thousand metric tons of CO2 equivalent) in 2005 in Finland to that in Germany?
Your answer should be very brief. 0.05. What is the ratio of the HFC emissions (in thousand metric tons of CO2 equivalent) of 2008 in Finland to that in Germany?
Your response must be concise. 0.05. What is the ratio of the HFC emissions (in thousand metric tons of CO2 equivalent) in 1990 in Finland to that in Greece?
Your answer should be very brief. 0. What is the ratio of the HFC emissions (in thousand metric tons of CO2 equivalent) in 2000 in Finland to that in Greece?
Your response must be concise. 0.16. What is the ratio of the HFC emissions (in thousand metric tons of CO2 equivalent) of 2005 in Finland to that in Greece?
Your response must be concise. 0.39. What is the ratio of the HFC emissions (in thousand metric tons of CO2 equivalent) in 2008 in Finland to that in Greece?
Offer a very short reply. 1. What is the ratio of the HFC emissions (in thousand metric tons of CO2 equivalent) of 2000 in Finland to that in Guatemala?
Provide a short and direct response. 2.4. What is the ratio of the HFC emissions (in thousand metric tons of CO2 equivalent) of 2005 in Finland to that in Guatemala?
Provide a short and direct response. 1.58. What is the ratio of the HFC emissions (in thousand metric tons of CO2 equivalent) of 2008 in Finland to that in Guatemala?
Make the answer very short. 1.51. What is the ratio of the HFC emissions (in thousand metric tons of CO2 equivalent) of 2000 in Finland to that in Hungary?
Offer a terse response. 0.88. What is the ratio of the HFC emissions (in thousand metric tons of CO2 equivalent) in 2005 in Finland to that in Hungary?
Keep it short and to the point. 0.63. What is the ratio of the HFC emissions (in thousand metric tons of CO2 equivalent) of 2008 in Finland to that in Hungary?
Offer a very short reply. 0.61. What is the ratio of the HFC emissions (in thousand metric tons of CO2 equivalent) of 1990 in France to that in Germany?
Your response must be concise. 1.8. What is the ratio of the HFC emissions (in thousand metric tons of CO2 equivalent) of 2000 in France to that in Germany?
Provide a short and direct response. 0.83. What is the ratio of the HFC emissions (in thousand metric tons of CO2 equivalent) of 2005 in France to that in Germany?
Give a very brief answer. 0.87. What is the ratio of the HFC emissions (in thousand metric tons of CO2 equivalent) in 2008 in France to that in Germany?
Provide a short and direct response. 0.87. What is the ratio of the HFC emissions (in thousand metric tons of CO2 equivalent) in 1990 in France to that in Greece?
Provide a short and direct response. 9.18. What is the ratio of the HFC emissions (in thousand metric tons of CO2 equivalent) in 2000 in France to that in Greece?
Offer a very short reply. 3.97. What is the ratio of the HFC emissions (in thousand metric tons of CO2 equivalent) in 2005 in France to that in Greece?
Offer a terse response. 6.66. What is the ratio of the HFC emissions (in thousand metric tons of CO2 equivalent) of 2008 in France to that in Greece?
Give a very brief answer. 16.85. What is the ratio of the HFC emissions (in thousand metric tons of CO2 equivalent) in 1990 in France to that in Guatemala?
Ensure brevity in your answer.  4.65e+04. What is the ratio of the HFC emissions (in thousand metric tons of CO2 equivalent) in 2000 in France to that in Guatemala?
Your response must be concise. 59.69. What is the ratio of the HFC emissions (in thousand metric tons of CO2 equivalent) in 2005 in France to that in Guatemala?
Provide a short and direct response. 26.65. What is the ratio of the HFC emissions (in thousand metric tons of CO2 equivalent) of 2008 in France to that in Guatemala?
Offer a very short reply. 25.31. What is the ratio of the HFC emissions (in thousand metric tons of CO2 equivalent) of 1990 in France to that in Hungary?
Provide a short and direct response. 4.65e+04. What is the ratio of the HFC emissions (in thousand metric tons of CO2 equivalent) in 2000 in France to that in Hungary?
Your answer should be very brief. 21.97. What is the ratio of the HFC emissions (in thousand metric tons of CO2 equivalent) in 2005 in France to that in Hungary?
Offer a terse response. 10.69. What is the ratio of the HFC emissions (in thousand metric tons of CO2 equivalent) of 2008 in France to that in Hungary?
Provide a short and direct response. 10.19. What is the ratio of the HFC emissions (in thousand metric tons of CO2 equivalent) of 1990 in Germany to that in Greece?
Your answer should be compact. 5.09. What is the ratio of the HFC emissions (in thousand metric tons of CO2 equivalent) in 2000 in Germany to that in Greece?
Your response must be concise. 4.76. What is the ratio of the HFC emissions (in thousand metric tons of CO2 equivalent) in 2005 in Germany to that in Greece?
Make the answer very short. 7.68. What is the ratio of the HFC emissions (in thousand metric tons of CO2 equivalent) of 2008 in Germany to that in Greece?
Offer a terse response. 19.46. What is the ratio of the HFC emissions (in thousand metric tons of CO2 equivalent) in 1990 in Germany to that in Guatemala?
Offer a terse response. 2.58e+04. What is the ratio of the HFC emissions (in thousand metric tons of CO2 equivalent) of 2000 in Germany to that in Guatemala?
Provide a short and direct response. 71.56. What is the ratio of the HFC emissions (in thousand metric tons of CO2 equivalent) of 2005 in Germany to that in Guatemala?
Give a very brief answer. 30.73. What is the ratio of the HFC emissions (in thousand metric tons of CO2 equivalent) of 2008 in Germany to that in Guatemala?
Keep it short and to the point. 29.24. What is the ratio of the HFC emissions (in thousand metric tons of CO2 equivalent) of 1990 in Germany to that in Hungary?
Your answer should be compact. 2.58e+04. What is the ratio of the HFC emissions (in thousand metric tons of CO2 equivalent) in 2000 in Germany to that in Hungary?
Make the answer very short. 26.34. What is the ratio of the HFC emissions (in thousand metric tons of CO2 equivalent) of 2005 in Germany to that in Hungary?
Your answer should be very brief. 12.33. What is the ratio of the HFC emissions (in thousand metric tons of CO2 equivalent) in 2008 in Germany to that in Hungary?
Ensure brevity in your answer.  11.78. What is the ratio of the HFC emissions (in thousand metric tons of CO2 equivalent) in 1990 in Greece to that in Guatemala?
Provide a short and direct response. 5072. What is the ratio of the HFC emissions (in thousand metric tons of CO2 equivalent) in 2000 in Greece to that in Guatemala?
Your response must be concise. 15.03. What is the ratio of the HFC emissions (in thousand metric tons of CO2 equivalent) in 2005 in Greece to that in Guatemala?
Ensure brevity in your answer.  4. What is the ratio of the HFC emissions (in thousand metric tons of CO2 equivalent) in 2008 in Greece to that in Guatemala?
Give a very brief answer. 1.5. What is the ratio of the HFC emissions (in thousand metric tons of CO2 equivalent) in 1990 in Greece to that in Hungary?
Your answer should be very brief. 5072. What is the ratio of the HFC emissions (in thousand metric tons of CO2 equivalent) in 2000 in Greece to that in Hungary?
Your answer should be very brief. 5.53. What is the ratio of the HFC emissions (in thousand metric tons of CO2 equivalent) in 2005 in Greece to that in Hungary?
Ensure brevity in your answer.  1.6. What is the ratio of the HFC emissions (in thousand metric tons of CO2 equivalent) in 2008 in Greece to that in Hungary?
Provide a succinct answer. 0.61. What is the ratio of the HFC emissions (in thousand metric tons of CO2 equivalent) of 1990 in Guatemala to that in Hungary?
Keep it short and to the point. 1. What is the ratio of the HFC emissions (in thousand metric tons of CO2 equivalent) in 2000 in Guatemala to that in Hungary?
Keep it short and to the point. 0.37. What is the ratio of the HFC emissions (in thousand metric tons of CO2 equivalent) of 2005 in Guatemala to that in Hungary?
Give a very brief answer. 0.4. What is the ratio of the HFC emissions (in thousand metric tons of CO2 equivalent) of 2008 in Guatemala to that in Hungary?
Offer a terse response. 0.4. What is the difference between the highest and the second highest HFC emissions (in thousand metric tons of CO2 equivalent) in 1990?
Ensure brevity in your answer.  2072.8. What is the difference between the highest and the second highest HFC emissions (in thousand metric tons of CO2 equivalent) of 2000?
Give a very brief answer. 1871.2. What is the difference between the highest and the second highest HFC emissions (in thousand metric tons of CO2 equivalent) of 2005?
Provide a short and direct response. 1949.9. What is the difference between the highest and the second highest HFC emissions (in thousand metric tons of CO2 equivalent) in 2008?
Provide a short and direct response. 2615.7. What is the difference between the highest and the lowest HFC emissions (in thousand metric tons of CO2 equivalent) of 1990?
Your answer should be very brief. 4654.2. What is the difference between the highest and the lowest HFC emissions (in thousand metric tons of CO2 equivalent) of 2000?
Give a very brief answer. 1.11e+04. What is the difference between the highest and the lowest HFC emissions (in thousand metric tons of CO2 equivalent) in 2005?
Offer a very short reply. 1.42e+04. What is the difference between the highest and the lowest HFC emissions (in thousand metric tons of CO2 equivalent) in 2008?
Provide a short and direct response. 1.88e+04. 